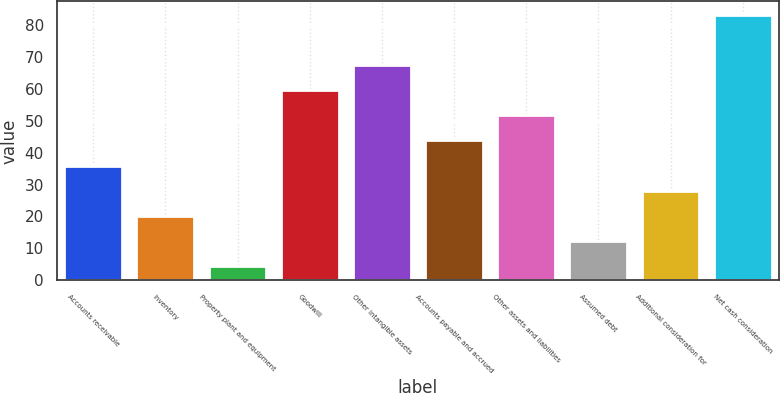Convert chart. <chart><loc_0><loc_0><loc_500><loc_500><bar_chart><fcel>Accounts receivable<fcel>Inventory<fcel>Property plant and equipment<fcel>Goodwill<fcel>Other intangible assets<fcel>Accounts payable and accrued<fcel>Other assets and liabilities<fcel>Assumed debt<fcel>Additional consideration for<fcel>Net cash consideration<nl><fcel>35.92<fcel>20.16<fcel>4.4<fcel>59.56<fcel>67.44<fcel>43.8<fcel>51.68<fcel>12.28<fcel>28.04<fcel>83.2<nl></chart> 